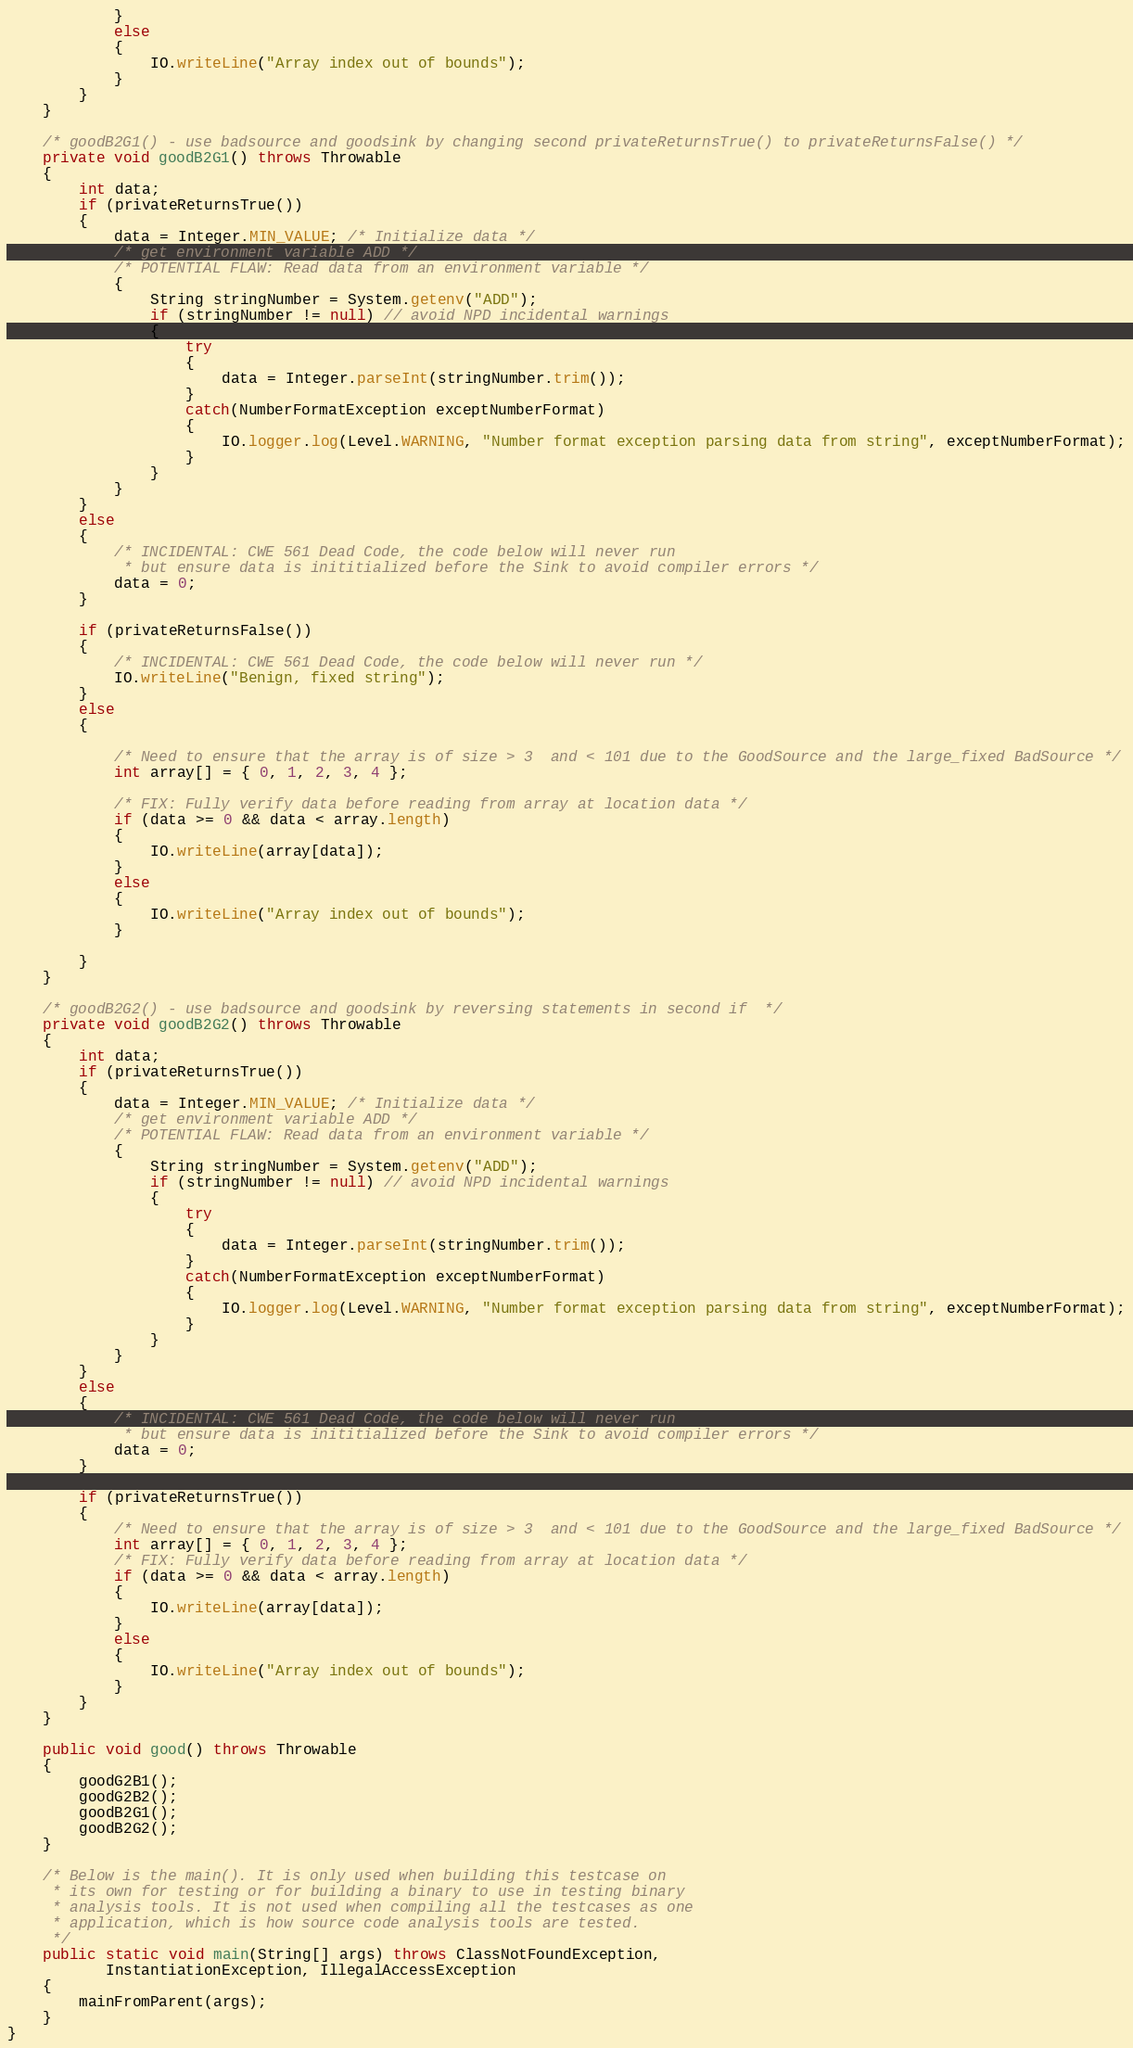Convert code to text. <code><loc_0><loc_0><loc_500><loc_500><_Java_>            }
            else
            {
                IO.writeLine("Array index out of bounds");
            }
        }
    }

    /* goodB2G1() - use badsource and goodsink by changing second privateReturnsTrue() to privateReturnsFalse() */
    private void goodB2G1() throws Throwable
    {
        int data;
        if (privateReturnsTrue())
        {
            data = Integer.MIN_VALUE; /* Initialize data */
            /* get environment variable ADD */
            /* POTENTIAL FLAW: Read data from an environment variable */
            {
                String stringNumber = System.getenv("ADD");
                if (stringNumber != null) // avoid NPD incidental warnings
                {
                    try
                    {
                        data = Integer.parseInt(stringNumber.trim());
                    }
                    catch(NumberFormatException exceptNumberFormat)
                    {
                        IO.logger.log(Level.WARNING, "Number format exception parsing data from string", exceptNumberFormat);
                    }
                }
            }
        }
        else
        {
            /* INCIDENTAL: CWE 561 Dead Code, the code below will never run
             * but ensure data is inititialized before the Sink to avoid compiler errors */
            data = 0;
        }

        if (privateReturnsFalse())
        {
            /* INCIDENTAL: CWE 561 Dead Code, the code below will never run */
            IO.writeLine("Benign, fixed string");
        }
        else
        {

            /* Need to ensure that the array is of size > 3  and < 101 due to the GoodSource and the large_fixed BadSource */
            int array[] = { 0, 1, 2, 3, 4 };

            /* FIX: Fully verify data before reading from array at location data */
            if (data >= 0 && data < array.length)
            {
                IO.writeLine(array[data]);
            }
            else
            {
                IO.writeLine("Array index out of bounds");
            }

        }
    }

    /* goodB2G2() - use badsource and goodsink by reversing statements in second if  */
    private void goodB2G2() throws Throwable
    {
        int data;
        if (privateReturnsTrue())
        {
            data = Integer.MIN_VALUE; /* Initialize data */
            /* get environment variable ADD */
            /* POTENTIAL FLAW: Read data from an environment variable */
            {
                String stringNumber = System.getenv("ADD");
                if (stringNumber != null) // avoid NPD incidental warnings
                {
                    try
                    {
                        data = Integer.parseInt(stringNumber.trim());
                    }
                    catch(NumberFormatException exceptNumberFormat)
                    {
                        IO.logger.log(Level.WARNING, "Number format exception parsing data from string", exceptNumberFormat);
                    }
                }
            }
        }
        else
        {
            /* INCIDENTAL: CWE 561 Dead Code, the code below will never run
             * but ensure data is inititialized before the Sink to avoid compiler errors */
            data = 0;
        }

        if (privateReturnsTrue())
        {
            /* Need to ensure that the array is of size > 3  and < 101 due to the GoodSource and the large_fixed BadSource */
            int array[] = { 0, 1, 2, 3, 4 };
            /* FIX: Fully verify data before reading from array at location data */
            if (data >= 0 && data < array.length)
            {
                IO.writeLine(array[data]);
            }
            else
            {
                IO.writeLine("Array index out of bounds");
            }
        }
    }

    public void good() throws Throwable
    {
        goodG2B1();
        goodG2B2();
        goodB2G1();
        goodB2G2();
    }

    /* Below is the main(). It is only used when building this testcase on
     * its own for testing or for building a binary to use in testing binary
     * analysis tools. It is not used when compiling all the testcases as one
     * application, which is how source code analysis tools are tested.
     */
    public static void main(String[] args) throws ClassNotFoundException,
           InstantiationException, IllegalAccessException
    {
        mainFromParent(args);
    }
}
</code> 